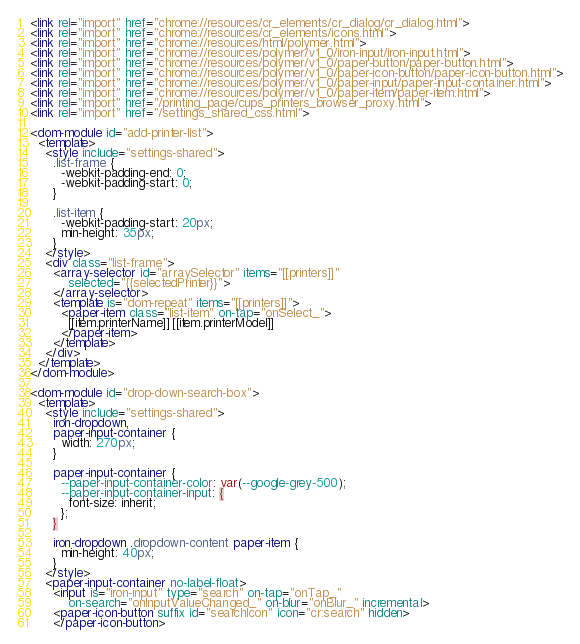<code> <loc_0><loc_0><loc_500><loc_500><_HTML_><link rel="import" href="chrome://resources/cr_elements/cr_dialog/cr_dialog.html">
<link rel="import" href="chrome://resources/cr_elements/icons.html">
<link rel="import" href="chrome://resources/html/polymer.html">
<link rel="import" href="chrome://resources/polymer/v1_0/iron-input/iron-input.html">
<link rel="import" href="chrome://resources/polymer/v1_0/paper-button/paper-button.html">
<link rel="import" href="chrome://resources/polymer/v1_0/paper-icon-button/paper-icon-button.html">
<link rel="import" href="chrome://resources/polymer/v1_0/paper-input/paper-input-container.html">
<link rel="import" href="chrome://resources/polymer/v1_0/paper-item/paper-item.html">
<link rel="import" href="/printing_page/cups_printers_browser_proxy.html">
<link rel="import" href="/settings_shared_css.html">

<dom-module id="add-printer-list">
  <template>
    <style include="settings-shared">
      .list-frame {
        -webkit-padding-end: 0;
        -webkit-padding-start: 0;
      }

      .list-item {
        -webkit-padding-start: 20px;
        min-height: 35px;
      }
    </style>
    <div class="list-frame">
      <array-selector id="arraySelector" items="[[printers]]"
          selected="{{selectedPrinter}}">
      </array-selector>
      <template is="dom-repeat" items="[[printers]]">
        <paper-item class="list-item" on-tap="onSelect_">
          [[item.printerName]] [[item.printerModel]]
        </paper-item>
      </template>
    </div>
  </template>
</dom-module>

<dom-module id="drop-down-search-box">
  <template>
    <style include="settings-shared">
      iron-dropdown,
      paper-input-container {
        width: 270px;
      }

      paper-input-container {
        --paper-input-container-color: var(--google-grey-500);
        --paper-input-container-input: {
          font-size: inherit;
        };
      }

      iron-dropdown .dropdown-content paper-item {
        min-height: 40px;
      }
    </style>
    <paper-input-container no-label-float>
      <input is="iron-input" type="search" on-tap="onTap_"
          on-search="onInputValueChanged_" on-blur="onBlur_" incremental>
      <paper-icon-button suffix id="searchIcon" icon="cr:search" hidden>
      </paper-icon-button></code> 